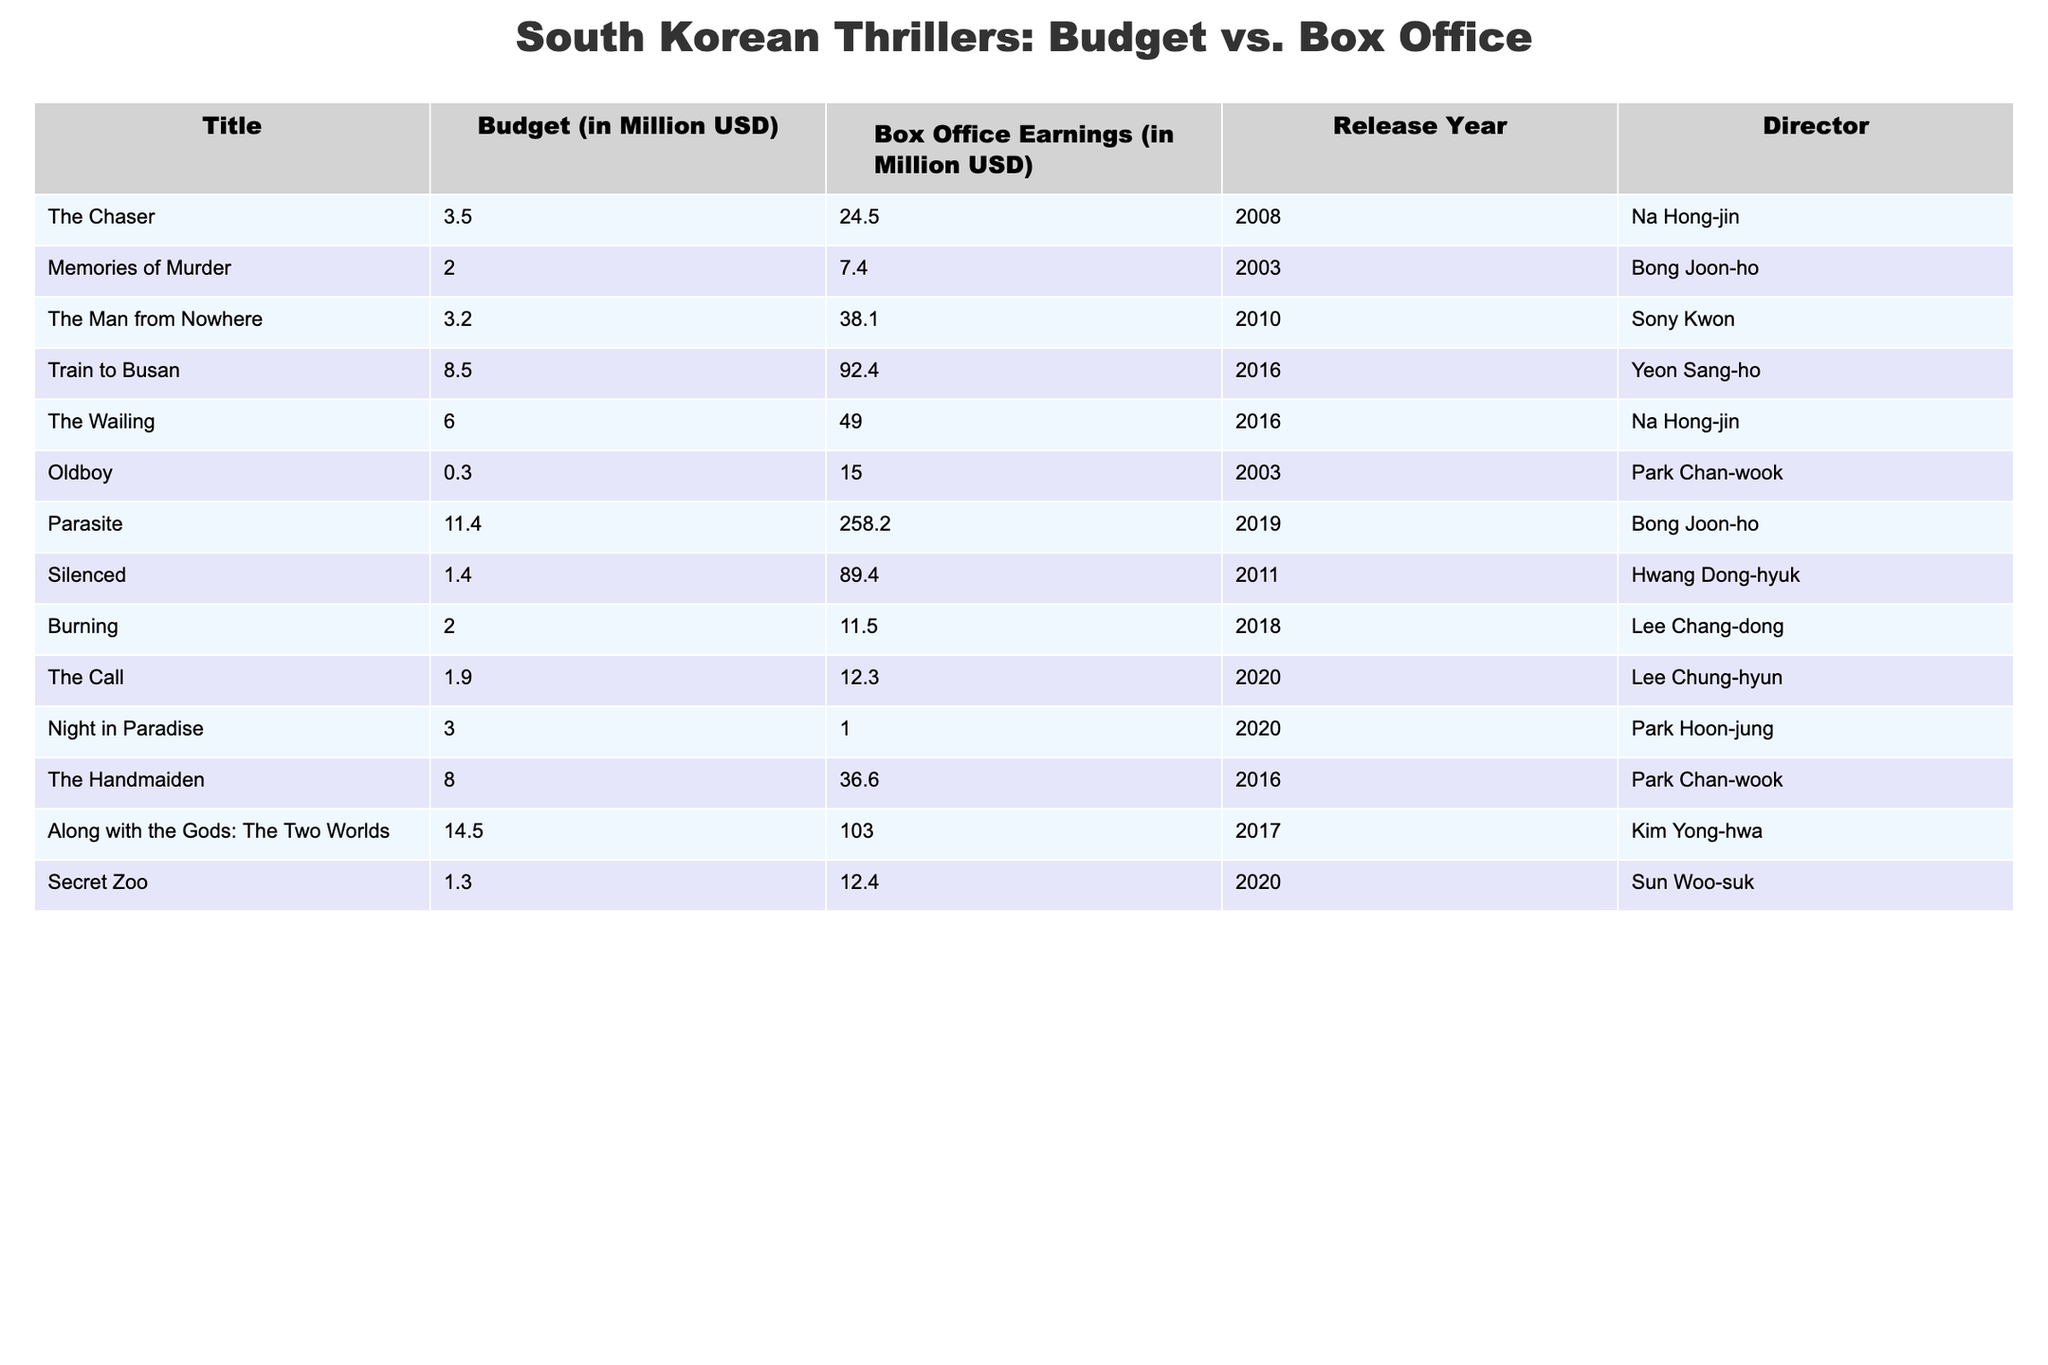What is the box office earning for "Parasite"? The table lists "Parasite" with box office earnings of 258.2 million USD.
Answer: 258.2 million USD Which film had the highest budget, and what was that budget? "Parasite" has the highest budget listed at 11.4 million USD.
Answer: 11.4 million USD What is the average budget of all the films? To calculate the average, sum all the budgets (3.5 + 2.0 + 3.2 + 8.5 + 6.0 + 0.3 + 11.4 + 1.4 + 2.0 + 1.9 + 3.0 + 8.0 + 14.5 + 1.3) which equals 63.1 million USD. There are 14 films, so the average budget is 63.1/14 = 4.5 million USD.
Answer: 4.5 million USD Did "Night in Paradise" earn more than its budget? "Night in Paradise" had a budget of 3.0 million USD and earned only 1.0 million USD at the box office, which is less than the budget.
Answer: No Which film produced the highest profit (box office earnings minus budget)? "Parasite" produced the highest profit. The earnings are 258.2 million USD, and the budget is 11.4 million USD. Thus, profit = 258.2 - 11.4 = 246.8 million USD.
Answer: 246.8 million USD How many films had box office earnings below 20 million USD? The box office earnings below 20 million USD belong to "Memories of Murder" (7.4), "Oldboy" (15.0), "Burning" (11.5), "The Call" (12.3), "Secret Zoo" (12.4), and "Night in Paradise" (1.0). That totals to 6 films.
Answer: 6 films Was the box office performance for "Train to Busan" significantly higher than its budget? "Train to Busan" had a budget of 8.5 million USD and earned 92.4 million USD. The difference is 92.4 - 8.5 = 83.9 million USD, indicating a significant higher performance.
Answer: Yes What was the total box office earnings for films directed by Bong Joon-ho? The films directed by Bong Joon-ho are "Memories of Murder" earning 7.4 million USD and "Parasite" earning 258.2 million USD. Their total earnings are 7.4 + 258.2 = 265.6 million USD.
Answer: 265.6 million USD 